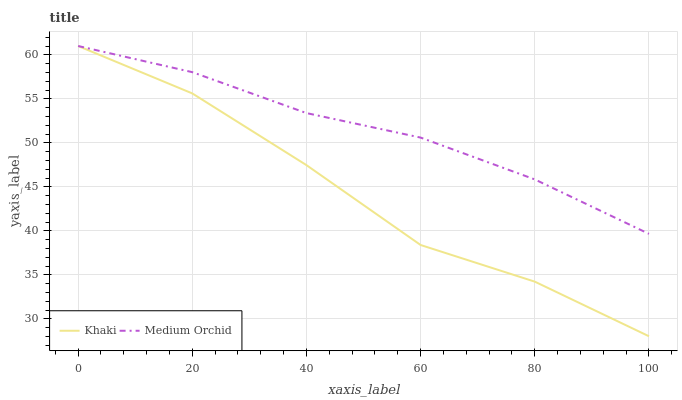Does Khaki have the minimum area under the curve?
Answer yes or no. Yes. Does Medium Orchid have the maximum area under the curve?
Answer yes or no. Yes. Does Khaki have the maximum area under the curve?
Answer yes or no. No. Is Medium Orchid the smoothest?
Answer yes or no. Yes. Is Khaki the roughest?
Answer yes or no. Yes. Is Khaki the smoothest?
Answer yes or no. No. Does Khaki have the highest value?
Answer yes or no. Yes. Does Khaki intersect Medium Orchid?
Answer yes or no. Yes. Is Khaki less than Medium Orchid?
Answer yes or no. No. Is Khaki greater than Medium Orchid?
Answer yes or no. No. 